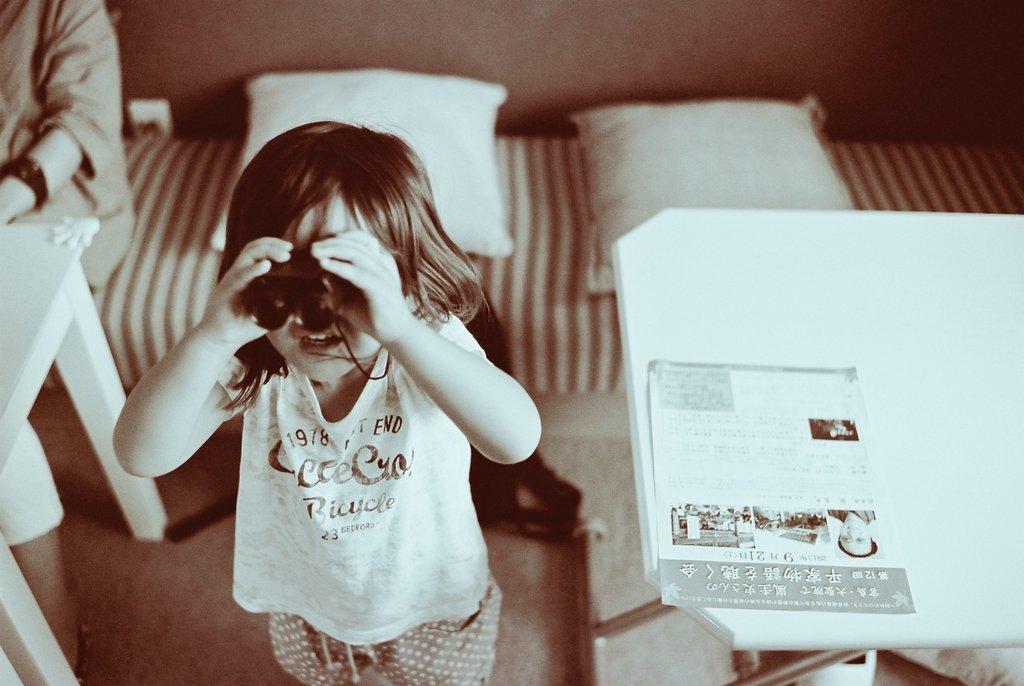Could you give a brief overview of what you see in this image? On the left side, there is a girl holding a binocular, standing and watching something. On the right side, there is a poster on a white table. In the background, there are pillows on a sofa on which there is a person sitting in front of a table. 